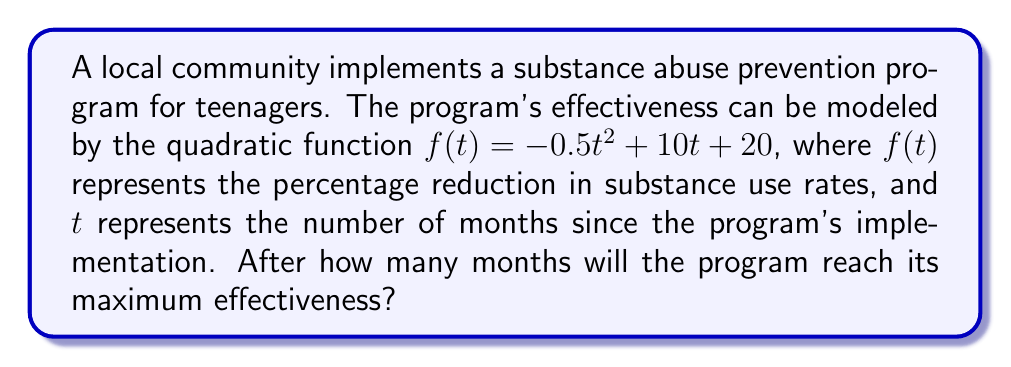Can you answer this question? To find the maximum effectiveness of the program, we need to determine the vertex of the parabola represented by the quadratic function. The vertex represents the highest point of the parabola, which in this case corresponds to the maximum reduction in substance use rates.

For a quadratic function in the form $f(t) = at^2 + bt + c$, the t-coordinate of the vertex is given by $t = -\frac{b}{2a}$.

1) Identify the coefficients:
   $a = -0.5$, $b = 10$, $c = 20$

2) Apply the formula:
   $t = -\frac{b}{2a} = -\frac{10}{2(-0.5)} = -\frac{10}{-1} = 10$

3) Therefore, the program reaches its maximum effectiveness after 10 months.

To verify:
- At $t = 9$: $f(9) = -0.5(9)^2 + 10(9) + 20 = -40.5 + 90 + 20 = 69.5$
- At $t = 10$: $f(10) = -0.5(10)^2 + 10(10) + 20 = -50 + 100 + 20 = 70$
- At $t = 11$: $f(11) = -0.5(11)^2 + 10(11) + 20 = -60.5 + 110 + 20 = 69.5$

This confirms that the maximum occurs at $t = 10$ months.
Answer: 10 months 